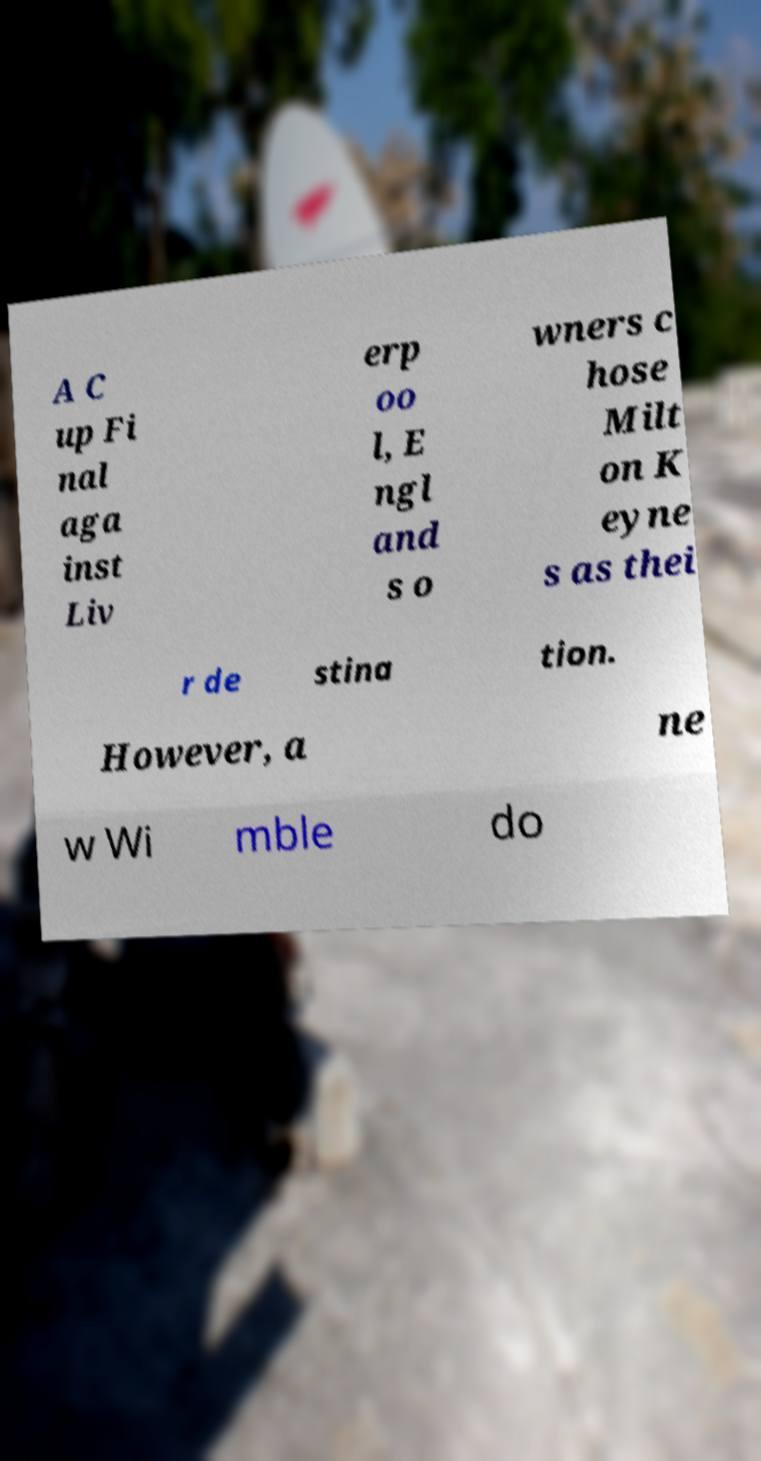Could you assist in decoding the text presented in this image and type it out clearly? A C up Fi nal aga inst Liv erp oo l, E ngl and s o wners c hose Milt on K eyne s as thei r de stina tion. However, a ne w Wi mble do 